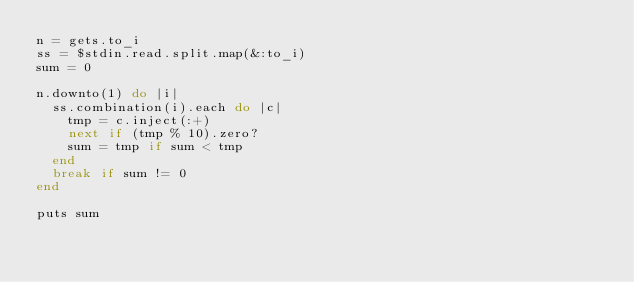<code> <loc_0><loc_0><loc_500><loc_500><_Ruby_>n = gets.to_i
ss = $stdin.read.split.map(&:to_i)
sum = 0

n.downto(1) do |i|
  ss.combination(i).each do |c|
    tmp = c.inject(:+)
    next if (tmp % 10).zero?
    sum = tmp if sum < tmp
  end
  break if sum != 0
end

puts sum</code> 